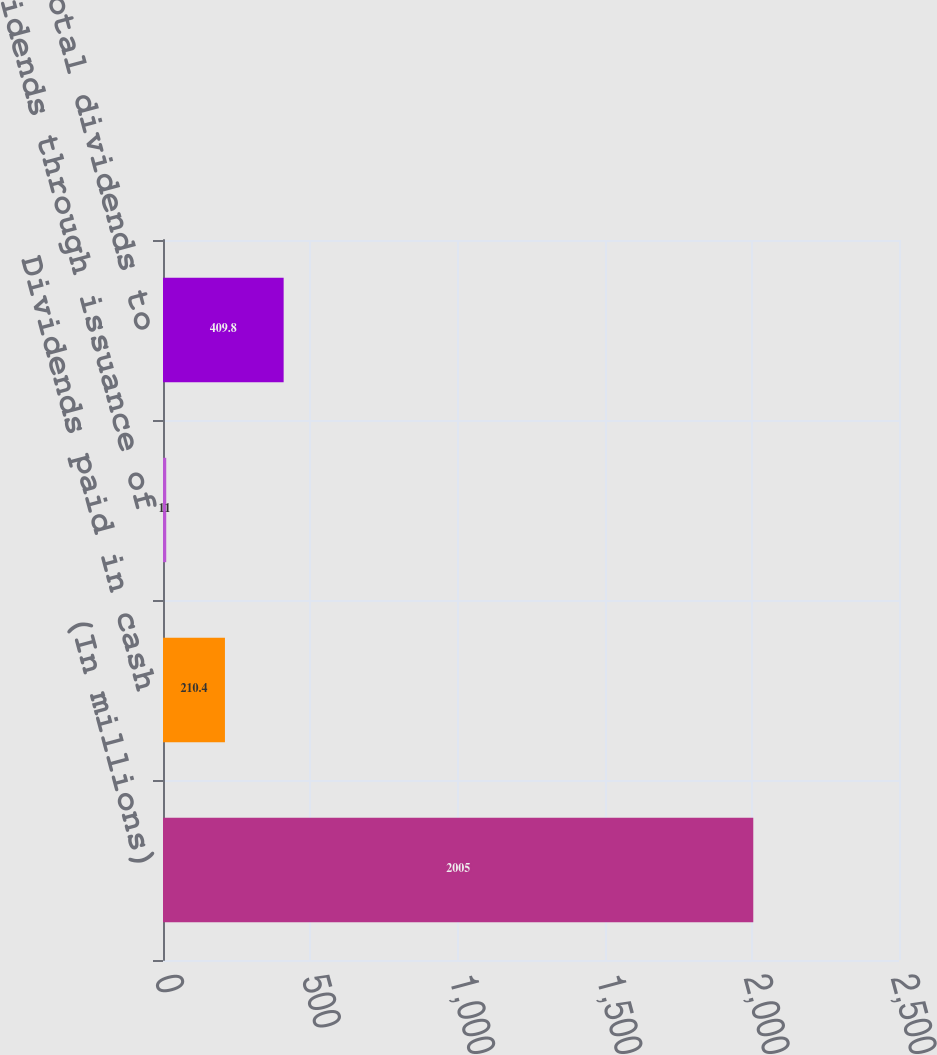Convert chart to OTSL. <chart><loc_0><loc_0><loc_500><loc_500><bar_chart><fcel>(In millions)<fcel>Dividends paid in cash<fcel>Dividends through issuance of<fcel>Total dividends to<nl><fcel>2005<fcel>210.4<fcel>11<fcel>409.8<nl></chart> 